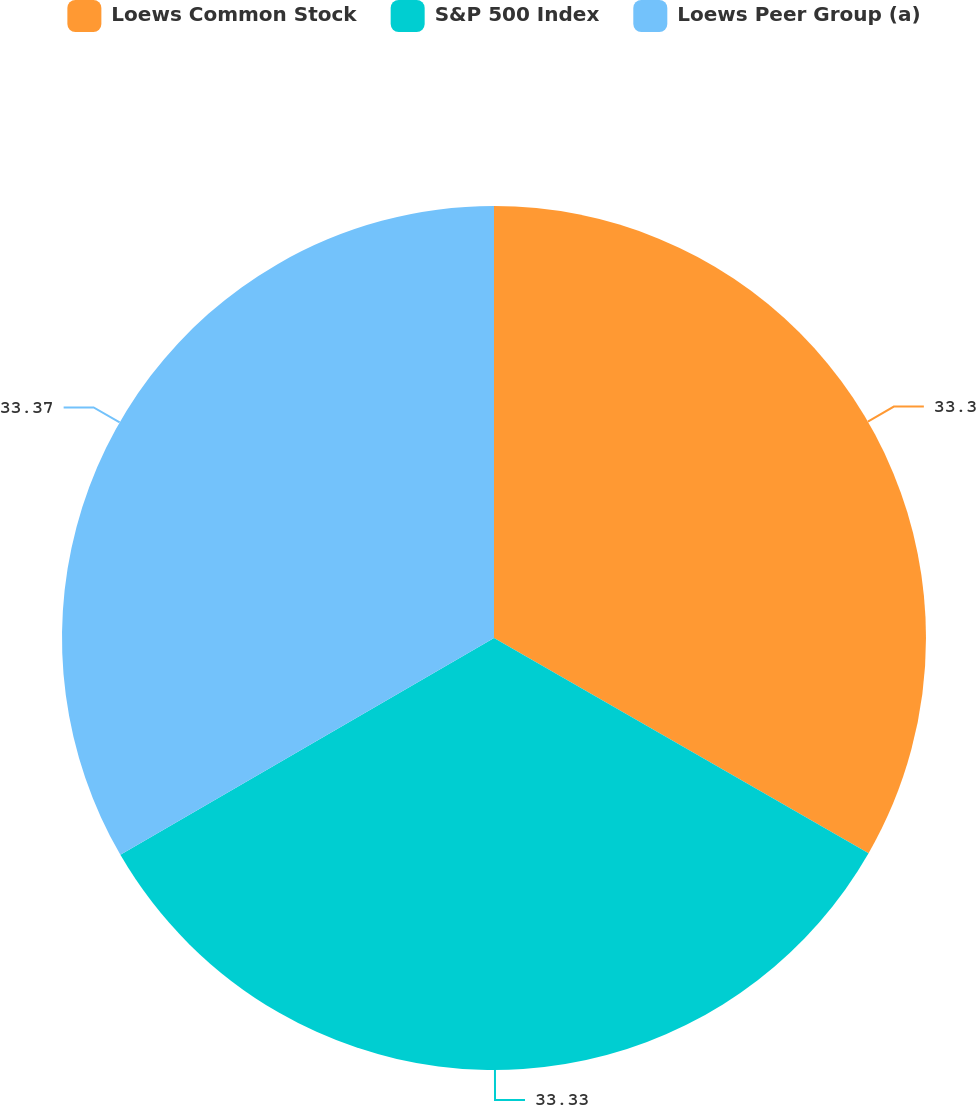Convert chart to OTSL. <chart><loc_0><loc_0><loc_500><loc_500><pie_chart><fcel>Loews Common Stock<fcel>S&P 500 Index<fcel>Loews Peer Group (a)<nl><fcel>33.3%<fcel>33.33%<fcel>33.37%<nl></chart> 